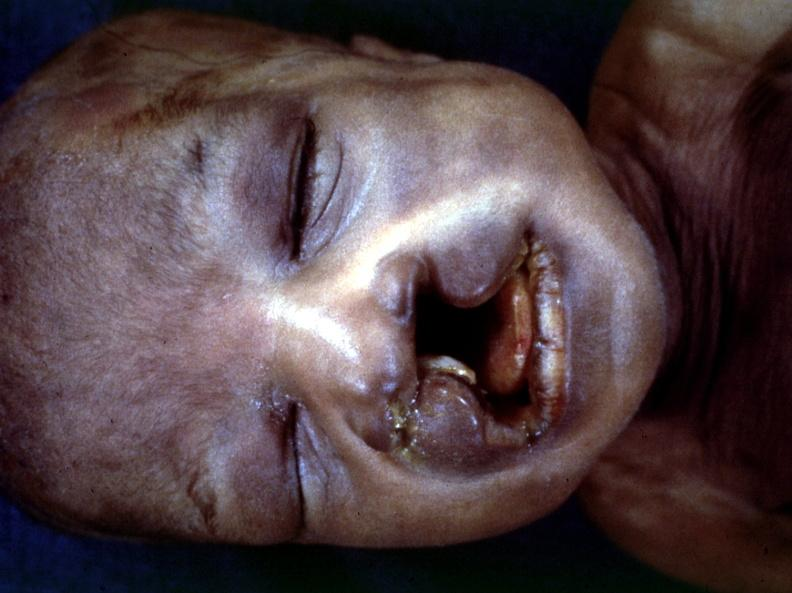s metastatic carcinoma breast present?
Answer the question using a single word or phrase. No 